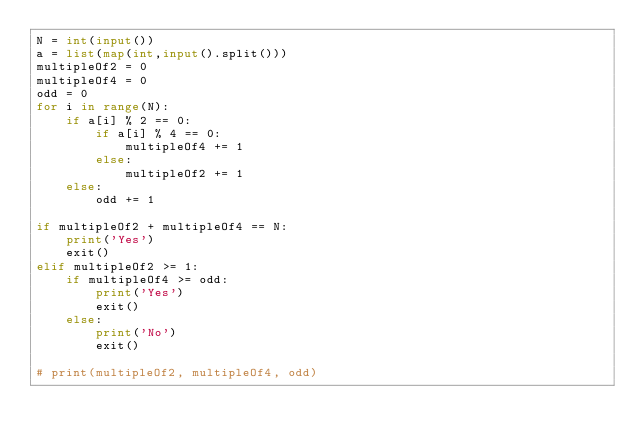<code> <loc_0><loc_0><loc_500><loc_500><_Python_>N = int(input())
a = list(map(int,input().split()))
multipleOf2 = 0
multipleOf4 = 0
odd = 0
for i in range(N):
    if a[i] % 2 == 0:
        if a[i] % 4 == 0:
            multipleOf4 += 1
        else:
            multipleOf2 += 1 
    else:
        odd += 1

if multipleOf2 + multipleOf4 == N:
    print('Yes')
    exit()
elif multipleOf2 >= 1:
    if multipleOf4 >= odd:
        print('Yes')
        exit()
    else:
        print('No')
        exit()
    
# print(multipleOf2, multipleOf4, odd)</code> 